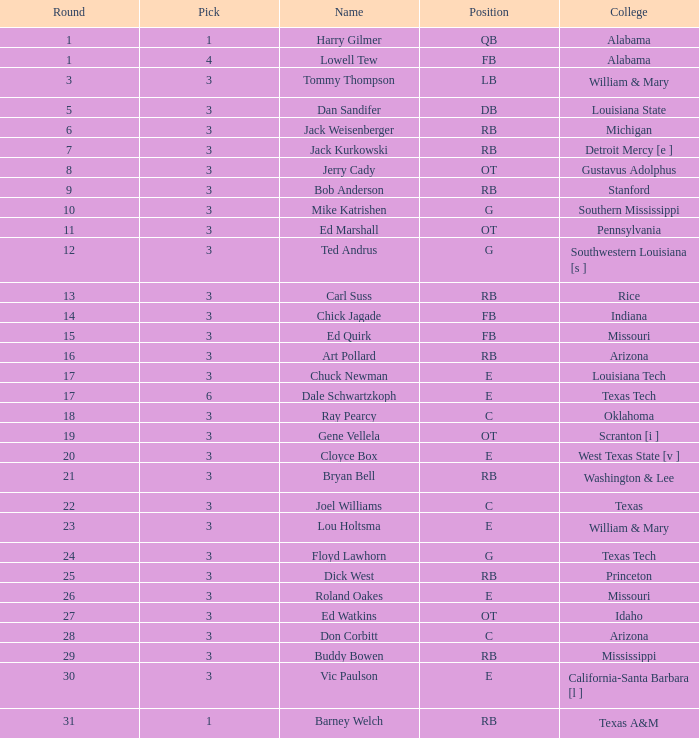Which Overall has a Name of bob anderson, and a Round smaller than 9? None. 